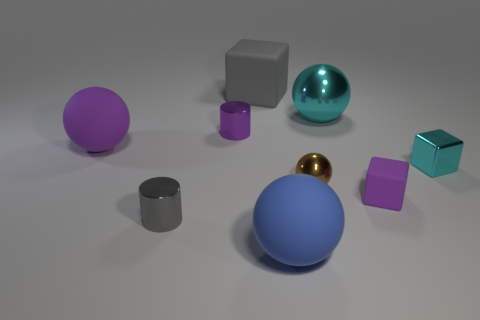What shape is the metallic thing that is the same color as the small rubber thing?
Offer a very short reply. Cylinder. What number of cyan cubes have the same material as the brown ball?
Your answer should be very brief. 1. The small rubber object is what color?
Offer a terse response. Purple. Is the shape of the tiny purple thing to the left of the cyan sphere the same as the small object to the right of the tiny purple cube?
Make the answer very short. No. What color is the tiny thing that is in front of the purple matte cube?
Provide a succinct answer. Gray. Are there fewer gray shiny cylinders that are behind the purple metal object than tiny brown balls left of the large gray rubber cube?
Your answer should be compact. No. What number of other objects are the same material as the big gray block?
Your answer should be very brief. 3. Do the large purple object and the big gray thing have the same material?
Keep it short and to the point. Yes. What number of other objects are the same size as the purple metal cylinder?
Your response must be concise. 4. There is a block that is on the right side of the rubber cube in front of the cyan metallic cube; what size is it?
Keep it short and to the point. Small. 